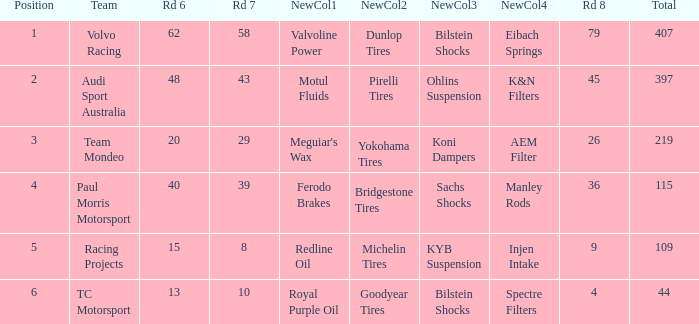What is the sum of values of Rd 7 with RD 6 less than 48 and Rd 8 less than 4 for TC Motorsport in a position greater than 1? None. 